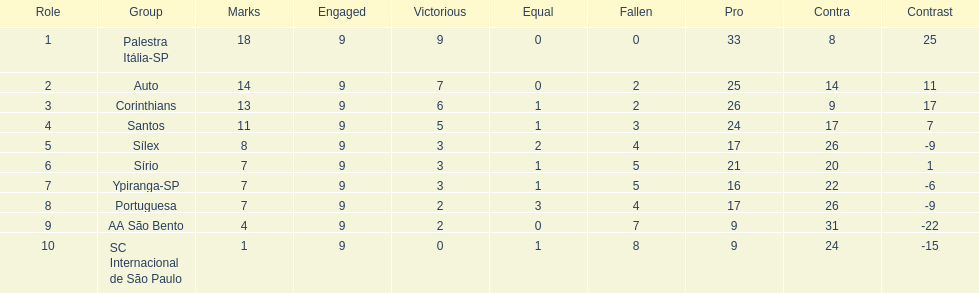In 1926 brazilian football,what was the total number of points scored? 90. 